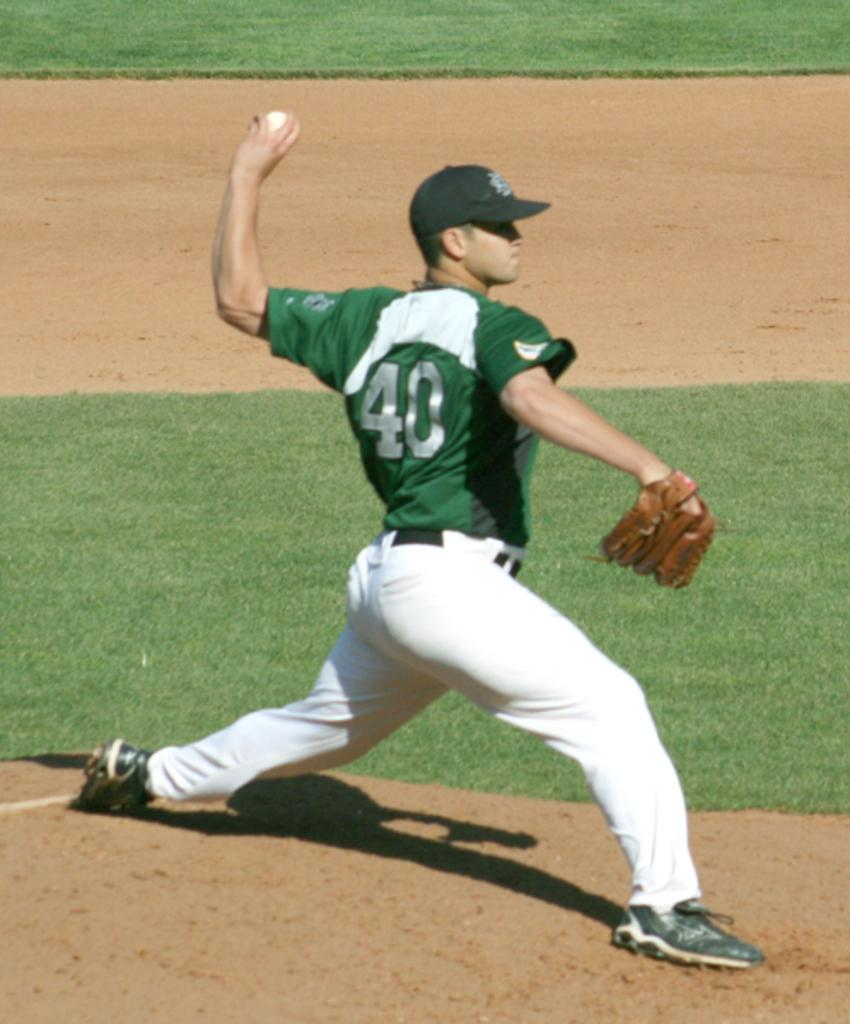<image>
Write a terse but informative summary of the picture. Player number 40 is the pitcher and he winds up to throw. 